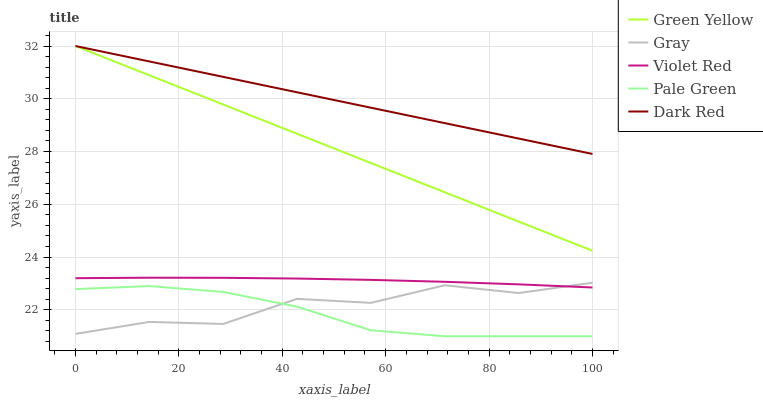Does Pale Green have the minimum area under the curve?
Answer yes or no. Yes. Does Dark Red have the maximum area under the curve?
Answer yes or no. Yes. Does Violet Red have the minimum area under the curve?
Answer yes or no. No. Does Violet Red have the maximum area under the curve?
Answer yes or no. No. Is Dark Red the smoothest?
Answer yes or no. Yes. Is Gray the roughest?
Answer yes or no. Yes. Is Violet Red the smoothest?
Answer yes or no. No. Is Violet Red the roughest?
Answer yes or no. No. Does Pale Green have the lowest value?
Answer yes or no. Yes. Does Violet Red have the lowest value?
Answer yes or no. No. Does Dark Red have the highest value?
Answer yes or no. Yes. Does Violet Red have the highest value?
Answer yes or no. No. Is Violet Red less than Green Yellow?
Answer yes or no. Yes. Is Violet Red greater than Pale Green?
Answer yes or no. Yes. Does Violet Red intersect Gray?
Answer yes or no. Yes. Is Violet Red less than Gray?
Answer yes or no. No. Is Violet Red greater than Gray?
Answer yes or no. No. Does Violet Red intersect Green Yellow?
Answer yes or no. No. 